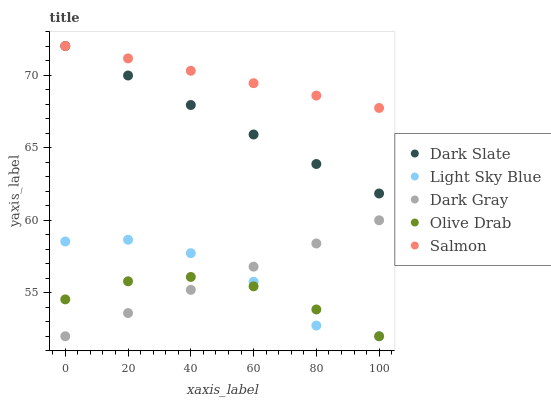Does Olive Drab have the minimum area under the curve?
Answer yes or no. Yes. Does Salmon have the maximum area under the curve?
Answer yes or no. Yes. Does Dark Slate have the minimum area under the curve?
Answer yes or no. No. Does Dark Slate have the maximum area under the curve?
Answer yes or no. No. Is Dark Slate the smoothest?
Answer yes or no. Yes. Is Light Sky Blue the roughest?
Answer yes or no. Yes. Is Light Sky Blue the smoothest?
Answer yes or no. No. Is Dark Slate the roughest?
Answer yes or no. No. Does Dark Gray have the lowest value?
Answer yes or no. Yes. Does Dark Slate have the lowest value?
Answer yes or no. No. Does Salmon have the highest value?
Answer yes or no. Yes. Does Light Sky Blue have the highest value?
Answer yes or no. No. Is Olive Drab less than Salmon?
Answer yes or no. Yes. Is Salmon greater than Dark Gray?
Answer yes or no. Yes. Does Olive Drab intersect Light Sky Blue?
Answer yes or no. Yes. Is Olive Drab less than Light Sky Blue?
Answer yes or no. No. Is Olive Drab greater than Light Sky Blue?
Answer yes or no. No. Does Olive Drab intersect Salmon?
Answer yes or no. No. 